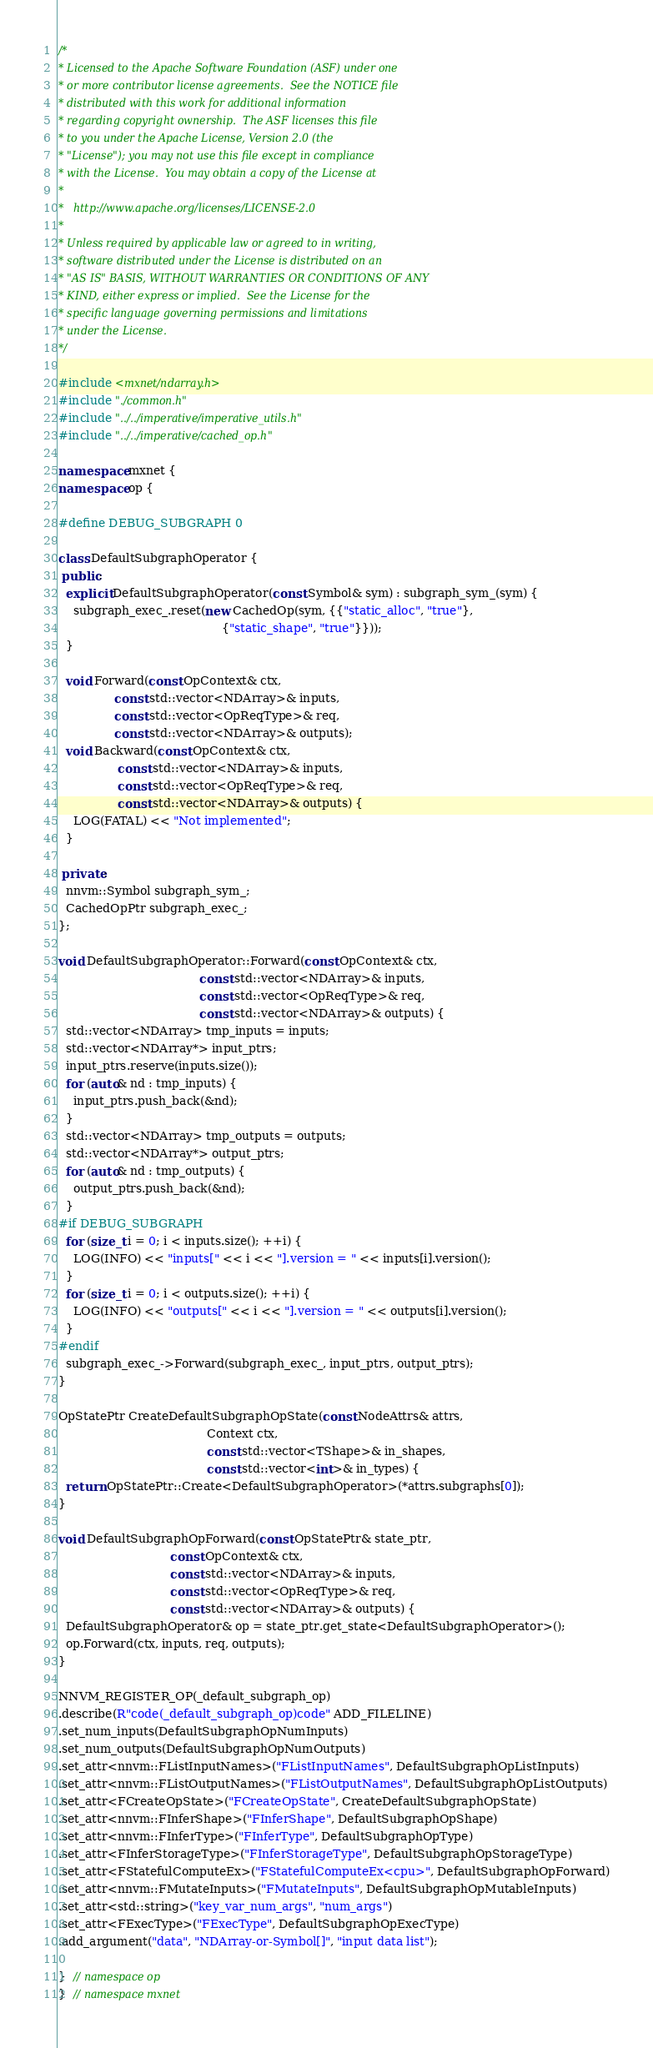Convert code to text. <code><loc_0><loc_0><loc_500><loc_500><_C++_>/*
* Licensed to the Apache Software Foundation (ASF) under one
* or more contributor license agreements.  See the NOTICE file
* distributed with this work for additional information
* regarding copyright ownership.  The ASF licenses this file
* to you under the Apache License, Version 2.0 (the
* "License"); you may not use this file except in compliance
* with the License.  You may obtain a copy of the License at
*
*   http://www.apache.org/licenses/LICENSE-2.0
*
* Unless required by applicable law or agreed to in writing,
* software distributed under the License is distributed on an
* "AS IS" BASIS, WITHOUT WARRANTIES OR CONDITIONS OF ANY
* KIND, either express or implied.  See the License for the
* specific language governing permissions and limitations
* under the License.
*/

#include <mxnet/ndarray.h>
#include "./common.h"
#include "../../imperative/imperative_utils.h"
#include "../../imperative/cached_op.h"

namespace mxnet {
namespace op {

#define DEBUG_SUBGRAPH 0

class DefaultSubgraphOperator {
 public:
  explicit DefaultSubgraphOperator(const Symbol& sym) : subgraph_sym_(sym) {
    subgraph_exec_.reset(new CachedOp(sym, {{"static_alloc", "true"},
                                            {"static_shape", "true"}}));
  }

  void Forward(const OpContext& ctx,
               const std::vector<NDArray>& inputs,
               const std::vector<OpReqType>& req,
               const std::vector<NDArray>& outputs);
  void Backward(const OpContext& ctx,
                const std::vector<NDArray>& inputs,
                const std::vector<OpReqType>& req,
                const std::vector<NDArray>& outputs) {
    LOG(FATAL) << "Not implemented";
  }

 private:
  nnvm::Symbol subgraph_sym_;
  CachedOpPtr subgraph_exec_;
};

void DefaultSubgraphOperator::Forward(const OpContext& ctx,
                                      const std::vector<NDArray>& inputs,
                                      const std::vector<OpReqType>& req,
                                      const std::vector<NDArray>& outputs) {
  std::vector<NDArray> tmp_inputs = inputs;
  std::vector<NDArray*> input_ptrs;
  input_ptrs.reserve(inputs.size());
  for (auto& nd : tmp_inputs) {
    input_ptrs.push_back(&nd);
  }
  std::vector<NDArray> tmp_outputs = outputs;
  std::vector<NDArray*> output_ptrs;
  for (auto& nd : tmp_outputs) {
    output_ptrs.push_back(&nd);
  }
#if DEBUG_SUBGRAPH
  for (size_t i = 0; i < inputs.size(); ++i) {
    LOG(INFO) << "inputs[" << i << "].version = " << inputs[i].version();
  }
  for (size_t i = 0; i < outputs.size(); ++i) {
    LOG(INFO) << "outputs[" << i << "].version = " << outputs[i].version();
  }
#endif
  subgraph_exec_->Forward(subgraph_exec_, input_ptrs, output_ptrs);
}

OpStatePtr CreateDefaultSubgraphOpState(const NodeAttrs& attrs,
                                        Context ctx,
                                        const std::vector<TShape>& in_shapes,
                                        const std::vector<int>& in_types) {
  return OpStatePtr::Create<DefaultSubgraphOperator>(*attrs.subgraphs[0]);
}

void DefaultSubgraphOpForward(const OpStatePtr& state_ptr,
                              const OpContext& ctx,
                              const std::vector<NDArray>& inputs,
                              const std::vector<OpReqType>& req,
                              const std::vector<NDArray>& outputs) {
  DefaultSubgraphOperator& op = state_ptr.get_state<DefaultSubgraphOperator>();
  op.Forward(ctx, inputs, req, outputs);
}

NNVM_REGISTER_OP(_default_subgraph_op)
.describe(R"code(_default_subgraph_op)code" ADD_FILELINE)
.set_num_inputs(DefaultSubgraphOpNumInputs)
.set_num_outputs(DefaultSubgraphOpNumOutputs)
.set_attr<nnvm::FListInputNames>("FListInputNames", DefaultSubgraphOpListInputs)
.set_attr<nnvm::FListOutputNames>("FListOutputNames", DefaultSubgraphOpListOutputs)
.set_attr<FCreateOpState>("FCreateOpState", CreateDefaultSubgraphOpState)
.set_attr<nnvm::FInferShape>("FInferShape", DefaultSubgraphOpShape)
.set_attr<nnvm::FInferType>("FInferType", DefaultSubgraphOpType)
.set_attr<FInferStorageType>("FInferStorageType", DefaultSubgraphOpStorageType)
.set_attr<FStatefulComputeEx>("FStatefulComputeEx<cpu>", DefaultSubgraphOpForward)
.set_attr<nnvm::FMutateInputs>("FMutateInputs", DefaultSubgraphOpMutableInputs)
.set_attr<std::string>("key_var_num_args", "num_args")
.set_attr<FExecType>("FExecType", DefaultSubgraphOpExecType)
.add_argument("data", "NDArray-or-Symbol[]", "input data list");

}  // namespace op
}  // namespace mxnet
</code> 